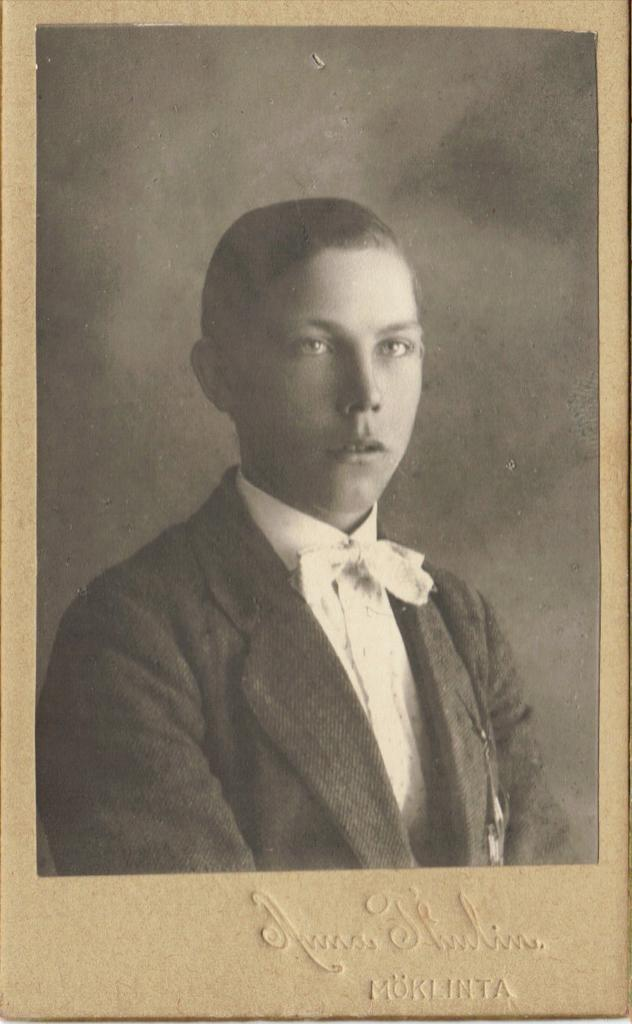What is the main subject of the image? The image contains a picture of a person. What color scheme is used in the image? The picture is in black and white. Is there any text present in the image? Yes, there is text at the bottom of the image. What type of punishment is being depicted in the image? There is no punishment being depicted in the image; it contains a picture of a person in black and white with text at the bottom. Can you see any rays or army personnel in the image? No, there are no rays or army personnel present in the image. 